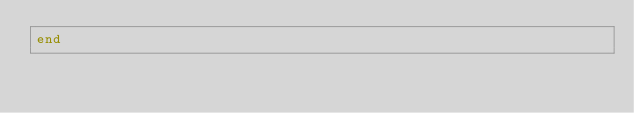<code> <loc_0><loc_0><loc_500><loc_500><_Ruby_>end
</code> 